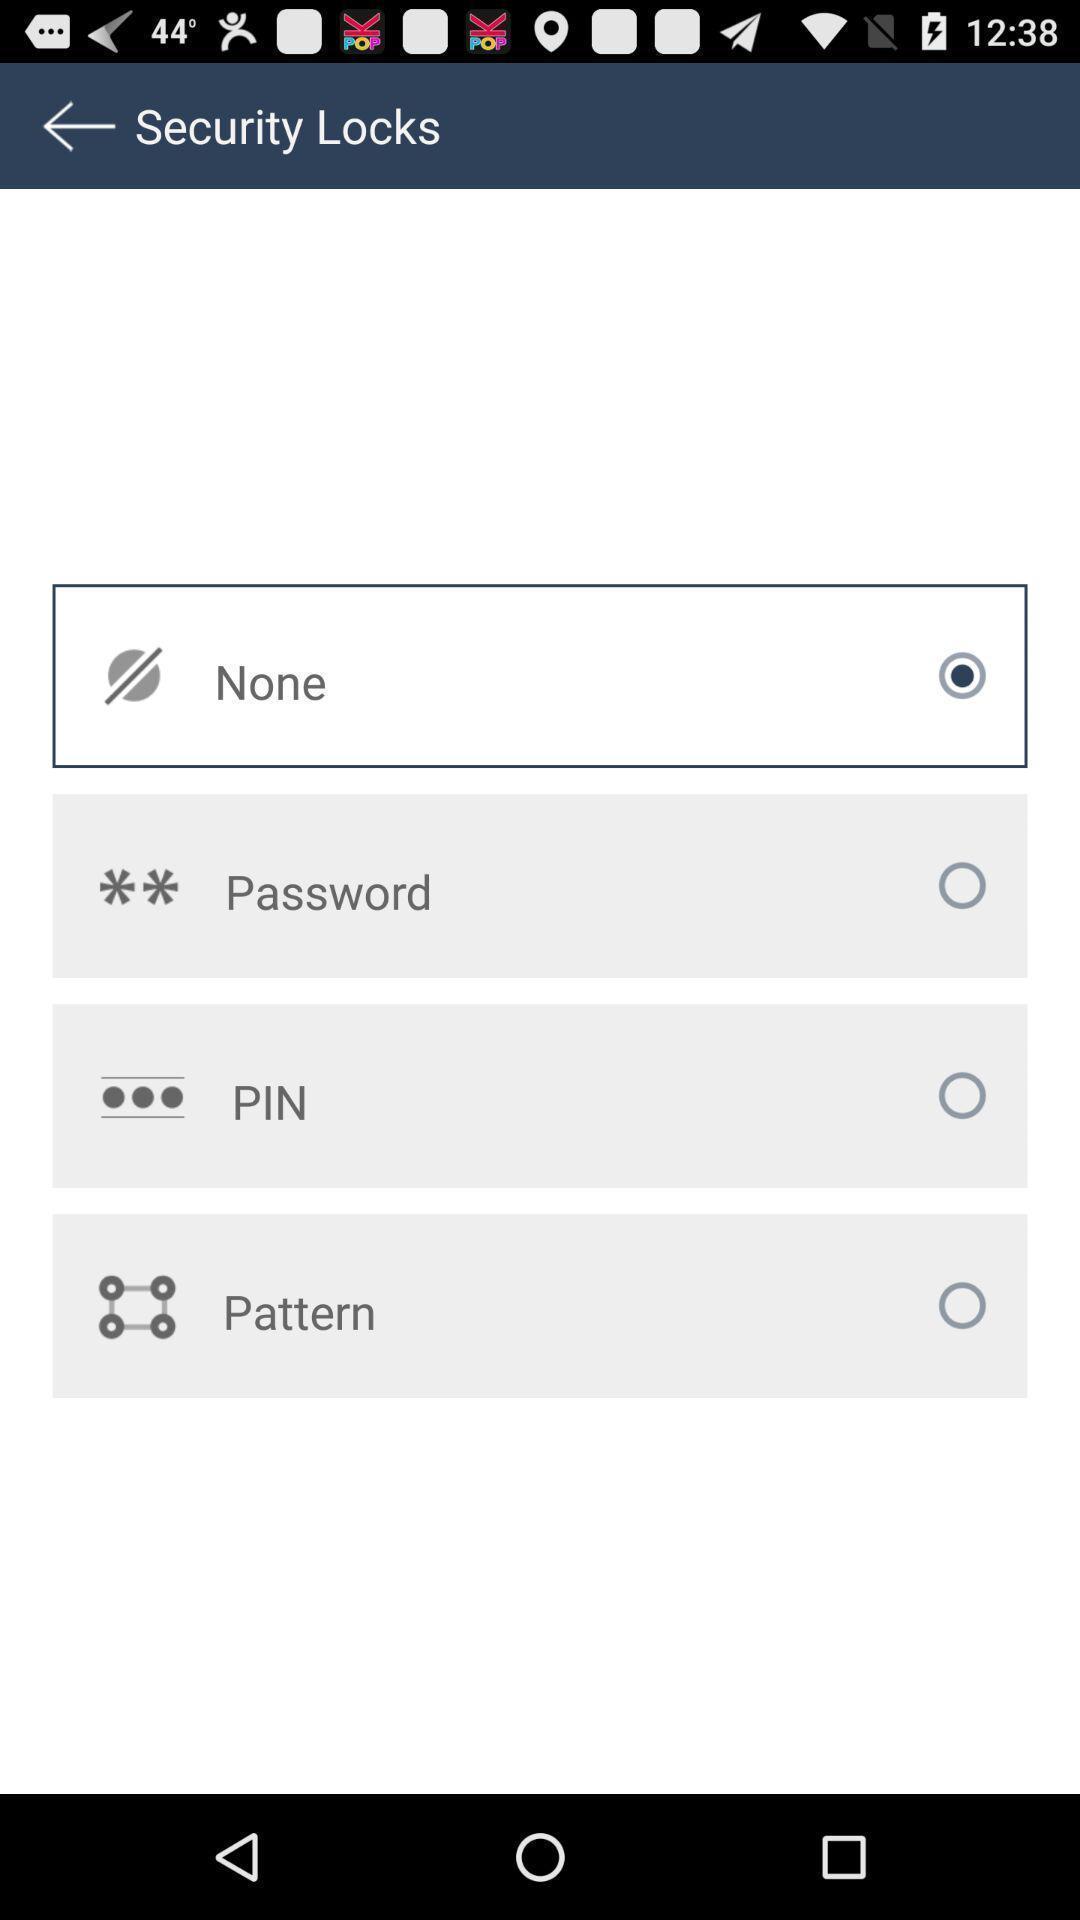Provide a textual representation of this image. Showing security locks page for an app. 